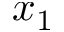<formula> <loc_0><loc_0><loc_500><loc_500>x _ { 1 }</formula> 